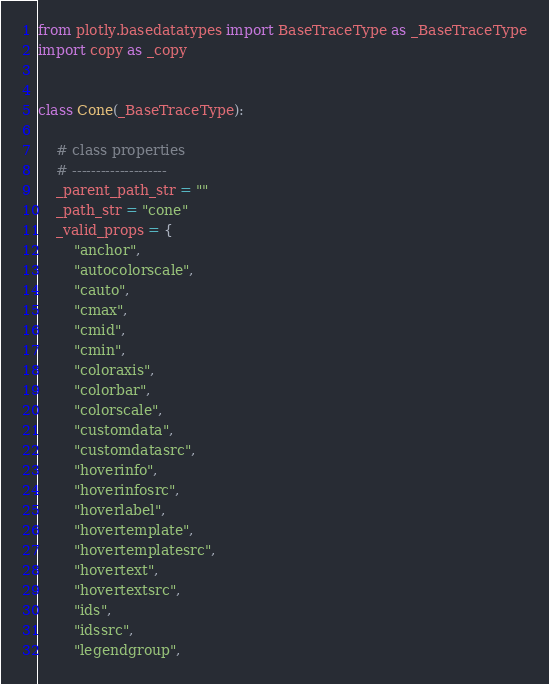Convert code to text. <code><loc_0><loc_0><loc_500><loc_500><_Python_>from plotly.basedatatypes import BaseTraceType as _BaseTraceType
import copy as _copy


class Cone(_BaseTraceType):

    # class properties
    # --------------------
    _parent_path_str = ""
    _path_str = "cone"
    _valid_props = {
        "anchor",
        "autocolorscale",
        "cauto",
        "cmax",
        "cmid",
        "cmin",
        "coloraxis",
        "colorbar",
        "colorscale",
        "customdata",
        "customdatasrc",
        "hoverinfo",
        "hoverinfosrc",
        "hoverlabel",
        "hovertemplate",
        "hovertemplatesrc",
        "hovertext",
        "hovertextsrc",
        "ids",
        "idssrc",
        "legendgroup",</code> 